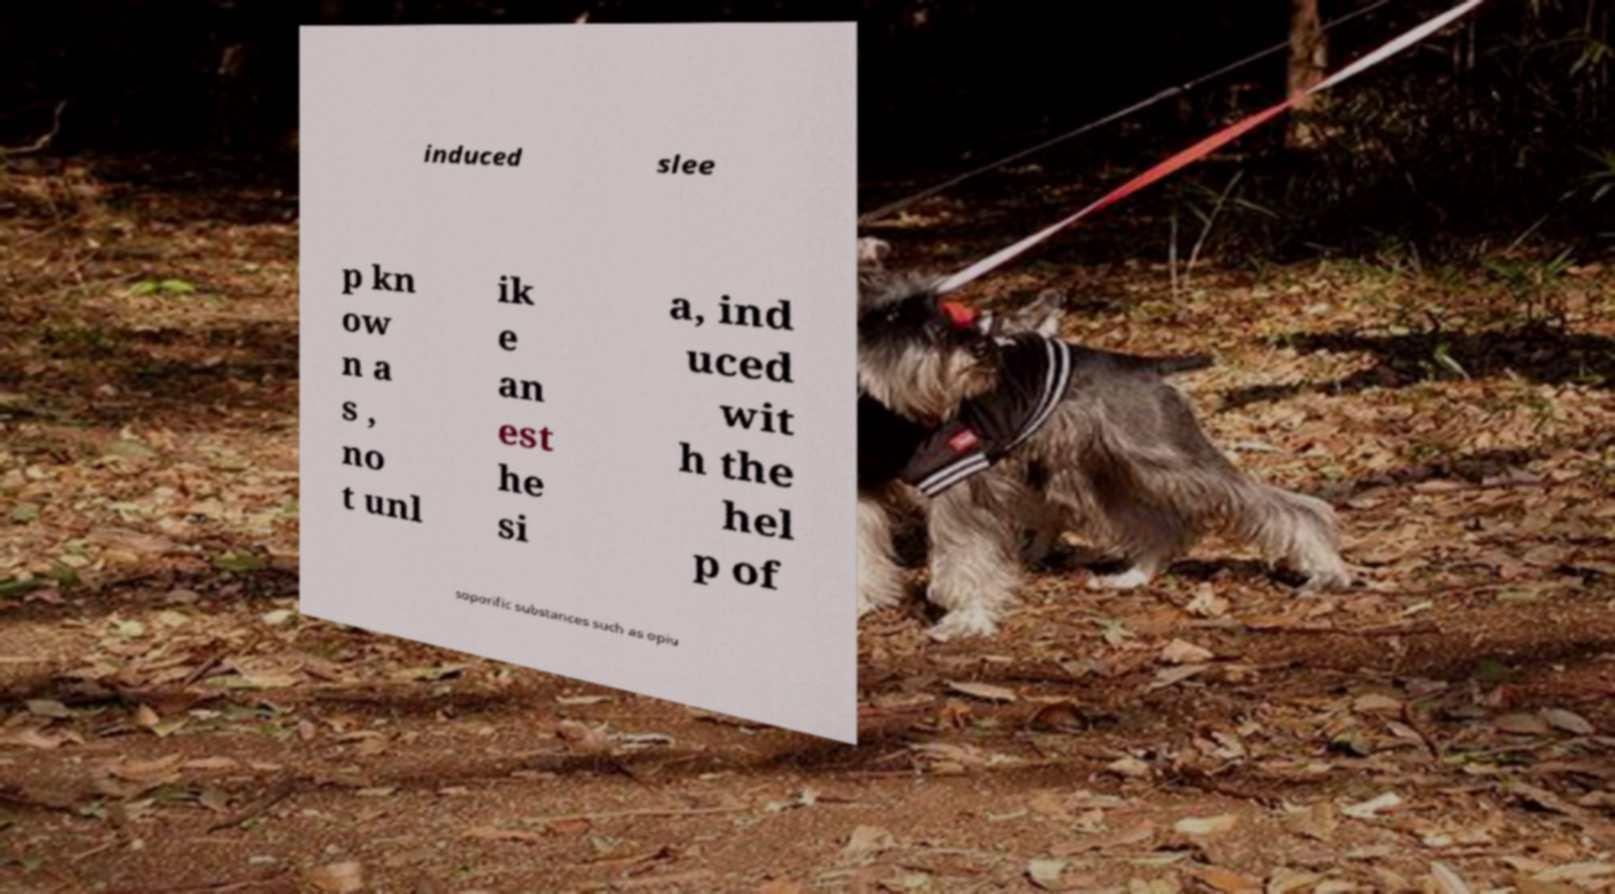For documentation purposes, I need the text within this image transcribed. Could you provide that? induced slee p kn ow n a s , no t unl ik e an est he si a, ind uced wit h the hel p of soporific substances such as opiu 